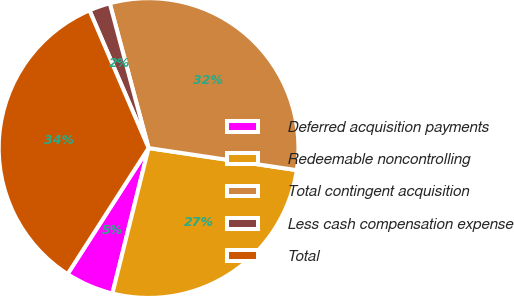Convert chart to OTSL. <chart><loc_0><loc_0><loc_500><loc_500><pie_chart><fcel>Deferred acquisition payments<fcel>Redeemable noncontrolling<fcel>Total contingent acquisition<fcel>Less cash compensation expense<fcel>Total<nl><fcel>5.21%<fcel>26.53%<fcel>31.53%<fcel>2.28%<fcel>34.46%<nl></chart> 